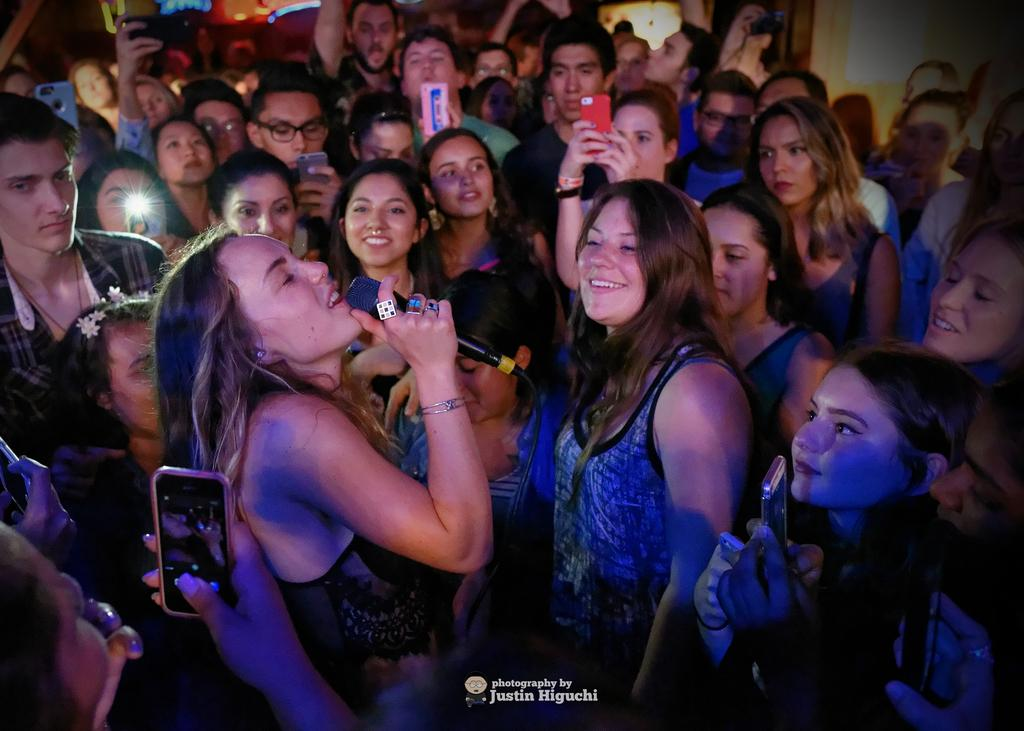What is the main subject of the image? The main subject of the image is a group of people. Can you describe what the woman in the image is doing? The woman is holding a microphone. What are some people in the image holding? Some people in the image are holding mobile phones. What type of alley can be seen in the background of the image? There is no alley present in the image; it features a group of people with a woman holding a microphone and some people holding mobile phones. 